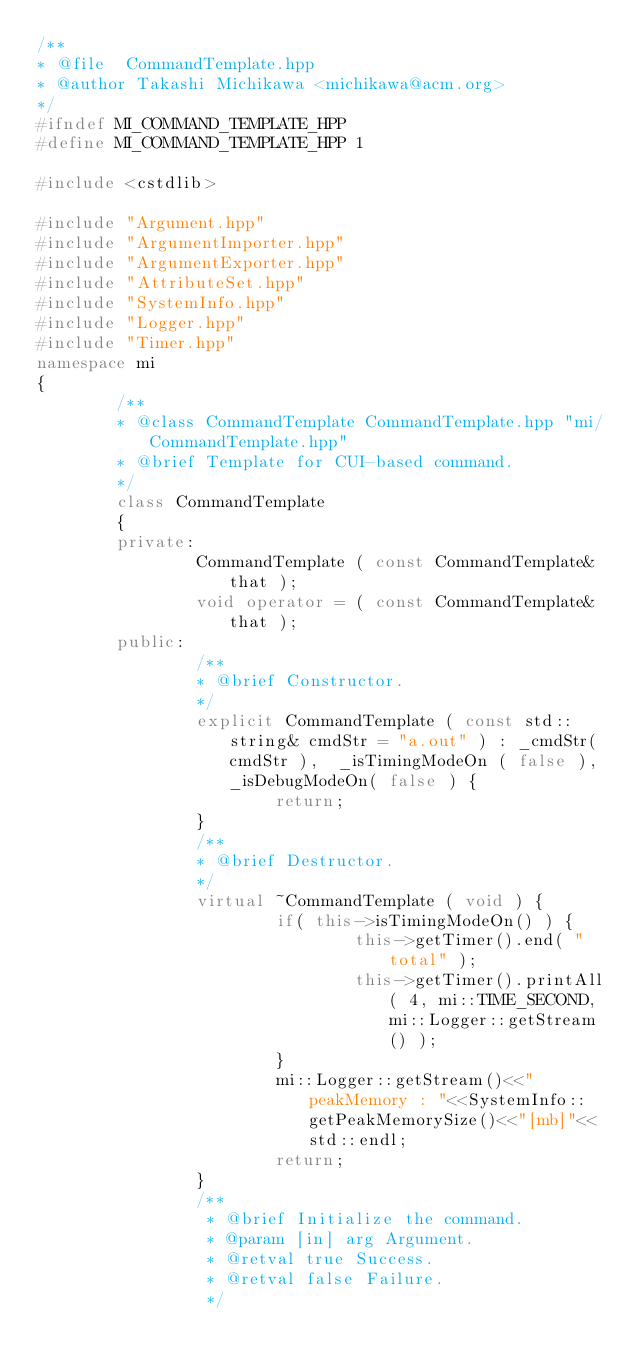<code> <loc_0><loc_0><loc_500><loc_500><_C++_>/**
* @file  CommandTemplate.hpp
* @author Takashi Michikawa <michikawa@acm.org>
*/
#ifndef MI_COMMAND_TEMPLATE_HPP
#define MI_COMMAND_TEMPLATE_HPP 1

#include <cstdlib>

#include "Argument.hpp"
#include "ArgumentImporter.hpp"
#include "ArgumentExporter.hpp"
#include "AttributeSet.hpp"
#include "SystemInfo.hpp"
#include "Logger.hpp"
#include "Timer.hpp"
namespace mi
{
        /**
        * @class CommandTemplate CommandTemplate.hpp "mi/CommandTemplate.hpp"
        * @brief Template for CUI-based command.
        */
        class CommandTemplate
        {
        private:
                CommandTemplate ( const CommandTemplate& that );
                void operator = ( const CommandTemplate& that );
        public:
                /**
                * @brief Constructor.
                */
                explicit CommandTemplate ( const std::string& cmdStr = "a.out" ) : _cmdStr( cmdStr ),  _isTimingModeOn ( false ), _isDebugModeOn( false ) {
                        return;
                }
                /**
                * @brief Destructor.
                */
                virtual ~CommandTemplate ( void ) {
                        if( this->isTimingModeOn() ) {
                                this->getTimer().end( "total" );
                                this->getTimer().printAll( 4, mi::TIME_SECOND, mi::Logger::getStream() );
                        }
                        mi::Logger::getStream()<<"peakMemory : "<<SystemInfo::getPeakMemorySize()<<"[mb]"<<std::endl;
                        return;
                }
                /**
                 * @brief Initialize the command.
                 * @param [in] arg Argument.
                 * @retval true Success.
                 * @retval false Failure.
                 */</code> 